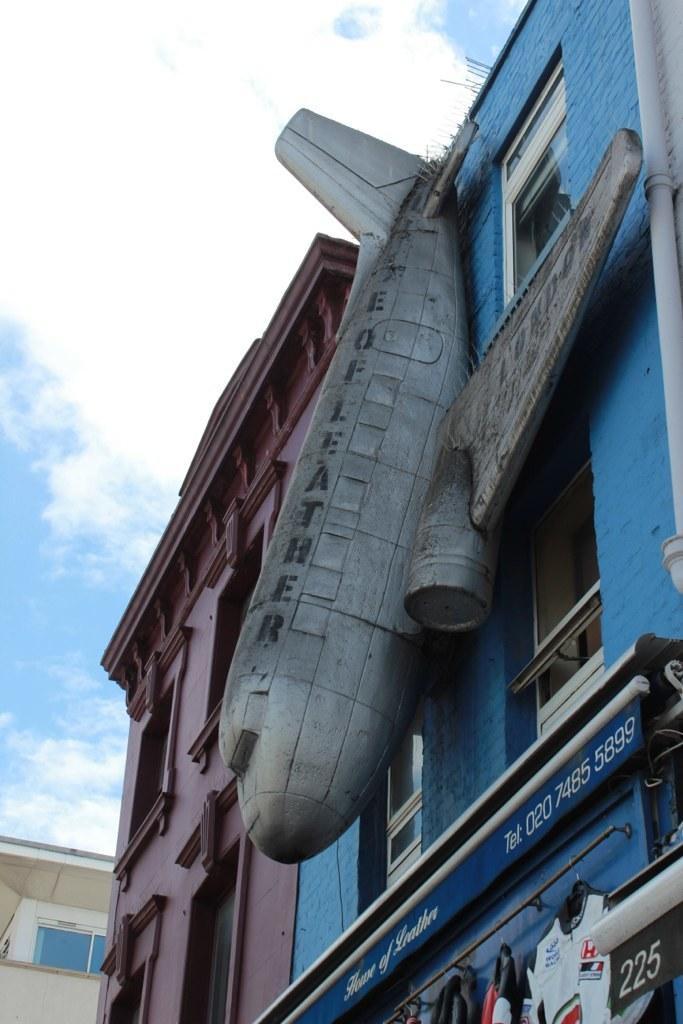Describe this image in one or two sentences. In this image I can see buildings. And to one of the building there is an aeroplane shape designed structure attached to it. Also there are boards, hangers with clothes and in the background there is sky. 